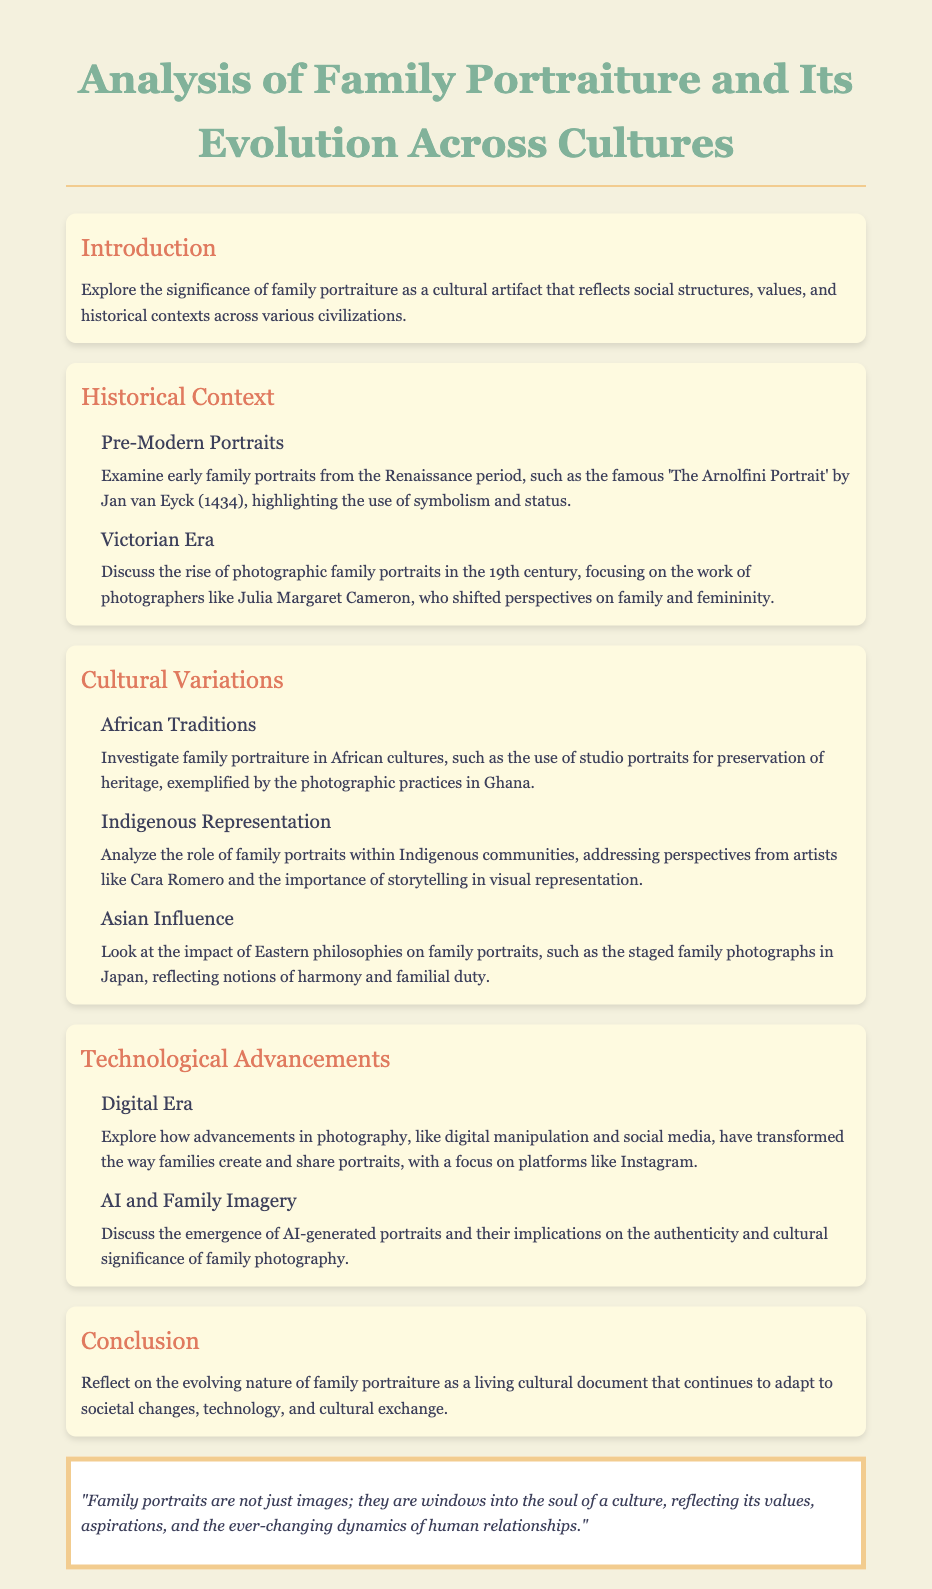What is the focus of the document? The document discusses the significance of family portraiture as a cultural artifact that reflects social structures, values, and historical contexts.
Answer: family portraiture Who painted 'The Arnolfini Portrait'? The document mentions Jan van Eyck as the artist of 'The Arnolfini Portrait'.
Answer: Jan van Eyck Which photographer is noted for shifting perspectives on family and femininity in the Victorian Era? The document references Julia Margaret Cameron's work in relation to family and femininity.
Answer: Julia Margaret Cameron What cultural aspect is highlighted in the discussion of African traditions? The document highlights the use of studio portraits for preservation of heritage in African cultures.
Answer: preservation of heritage What technological advancement is discussed in relation to family portraits in the digital era? The document explains advancements like digital manipulation and social media have transformed family photography.
Answer: digital manipulation Who are mentioned as artists addressing Indigenous representation? The document specifically mentions Cara Romero in the context of Indigenous family portraiture.
Answer: Cara Romero What notion is reflected in the staged family photographs in Japan? The document states that staged family photographs in Japan reflect notions of harmony and familial duty.
Answer: harmony What is one implication of AI-generated portraits discussed in the document? The document discusses the implications on the authenticity of family photography due to AI-generated portraits.
Answer: authenticity How does the document describe family portraits? The document describes family portraits as windows into the soul of a culture.
Answer: windows into the soul of a culture 